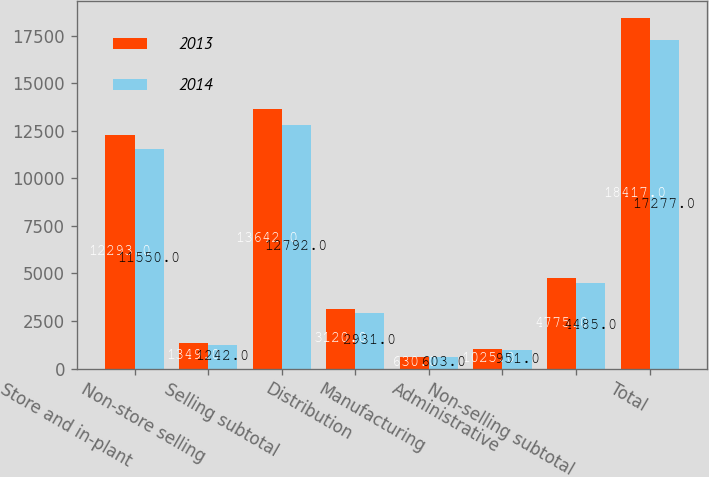Convert chart. <chart><loc_0><loc_0><loc_500><loc_500><stacked_bar_chart><ecel><fcel>Store and in-plant<fcel>Non-store selling<fcel>Selling subtotal<fcel>Distribution<fcel>Manufacturing<fcel>Administrative<fcel>Non-selling subtotal<fcel>Total<nl><fcel>2013<fcel>12293<fcel>1349<fcel>13642<fcel>3120<fcel>630<fcel>1025<fcel>4775<fcel>18417<nl><fcel>2014<fcel>11550<fcel>1242<fcel>12792<fcel>2931<fcel>603<fcel>951<fcel>4485<fcel>17277<nl></chart> 